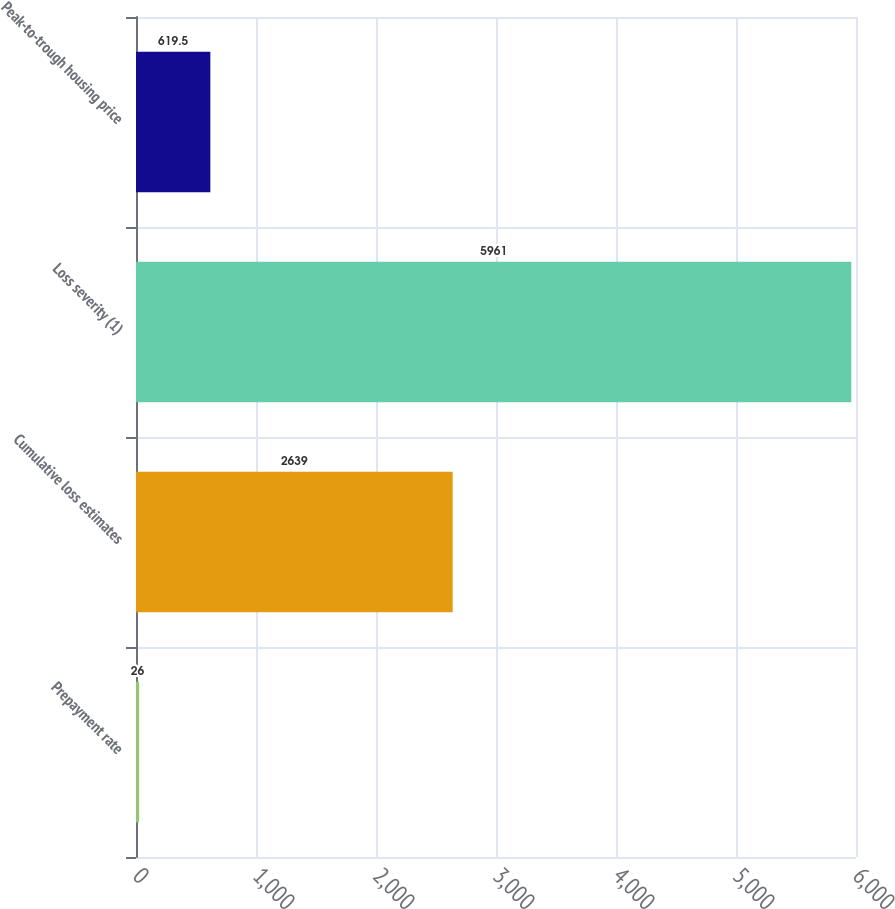Convert chart. <chart><loc_0><loc_0><loc_500><loc_500><bar_chart><fcel>Prepayment rate<fcel>Cumulative loss estimates<fcel>Loss severity (1)<fcel>Peak-to-trough housing price<nl><fcel>26<fcel>2639<fcel>5961<fcel>619.5<nl></chart> 